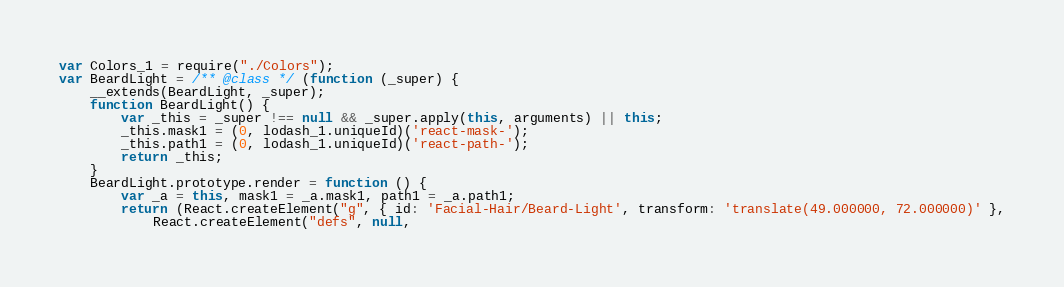<code> <loc_0><loc_0><loc_500><loc_500><_JavaScript_>var Colors_1 = require("./Colors");
var BeardLight = /** @class */ (function (_super) {
    __extends(BeardLight, _super);
    function BeardLight() {
        var _this = _super !== null && _super.apply(this, arguments) || this;
        _this.mask1 = (0, lodash_1.uniqueId)('react-mask-');
        _this.path1 = (0, lodash_1.uniqueId)('react-path-');
        return _this;
    }
    BeardLight.prototype.render = function () {
        var _a = this, mask1 = _a.mask1, path1 = _a.path1;
        return (React.createElement("g", { id: 'Facial-Hair/Beard-Light', transform: 'translate(49.000000, 72.000000)' },
            React.createElement("defs", null,</code> 